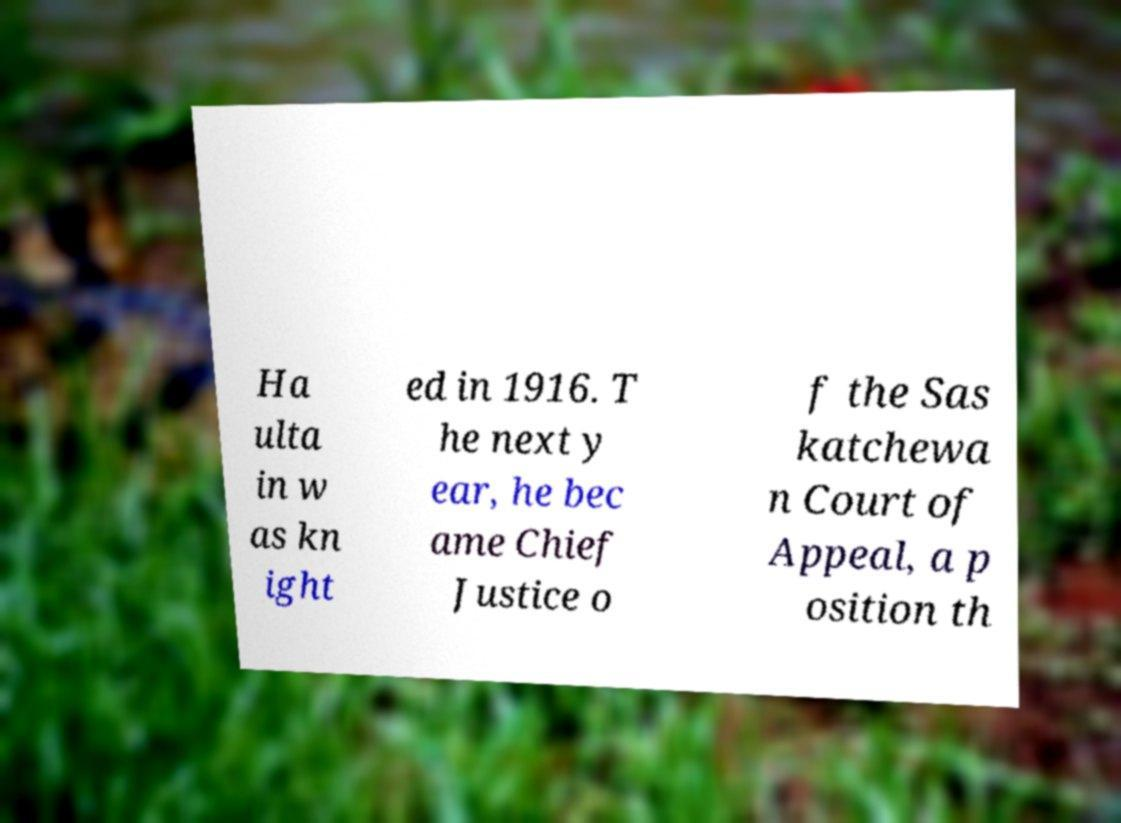Can you read and provide the text displayed in the image?This photo seems to have some interesting text. Can you extract and type it out for me? Ha ulta in w as kn ight ed in 1916. T he next y ear, he bec ame Chief Justice o f the Sas katchewa n Court of Appeal, a p osition th 